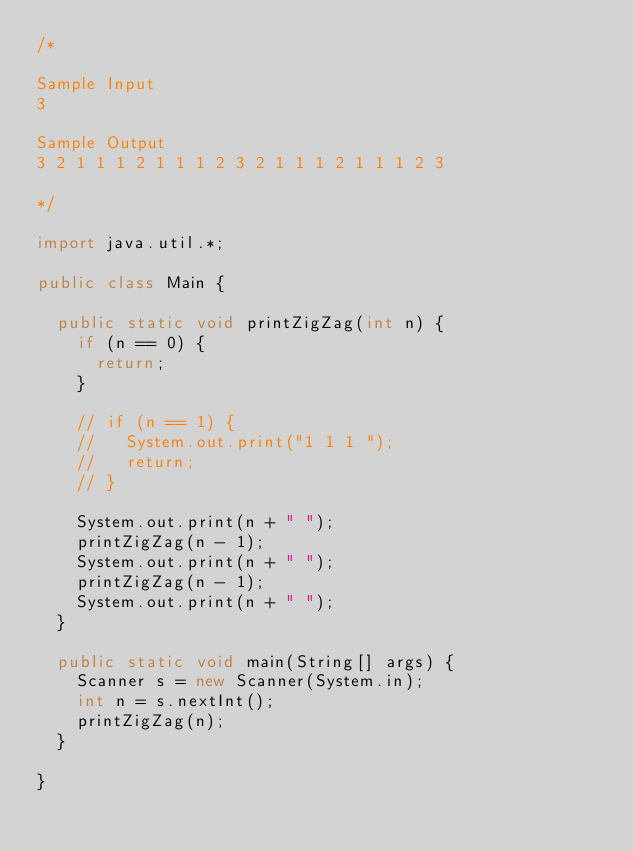<code> <loc_0><loc_0><loc_500><loc_500><_Java_>/* 

Sample Input
3

Sample Output
3 2 1 1 1 2 1 1 1 2 3 2 1 1 1 2 1 1 1 2 3

*/

import java.util.*;

public class Main {

  public static void printZigZag(int n) {
    if (n == 0) {
      return;
    }

    // if (n == 1) {
    //   System.out.print("1 1 1 ");
    //   return;
    // }

    System.out.print(n + " ");
    printZigZag(n - 1);
    System.out.print(n + " ");
    printZigZag(n - 1);
    System.out.print(n + " ");
  }

  public static void main(String[] args) {
    Scanner s = new Scanner(System.in);
    int n = s.nextInt();
    printZigZag(n);
  }

}
</code> 